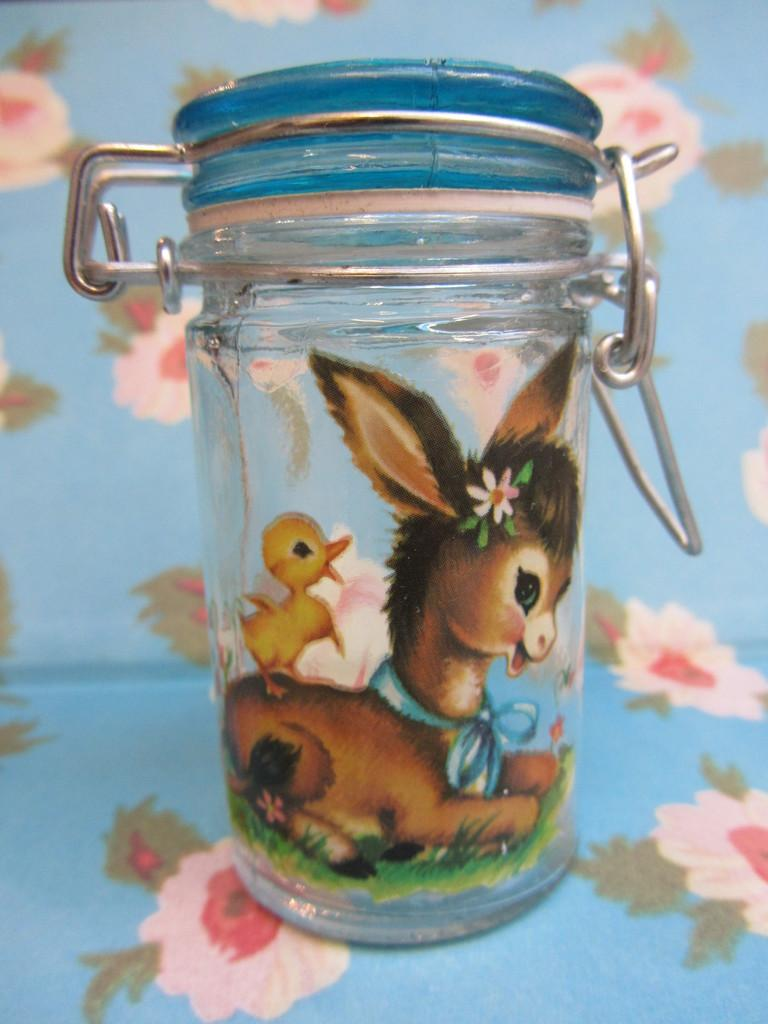What type of container is visible in the image? There is a glass container in the image. What is depicted on the glass container? The glass container has animal paintings on it. What can be seen in the background of the image? There are flowers paintings on a blue surface in the background of the image. What type of glove is being worn by the tiger in the image? There is no tiger or glove present in the image. 